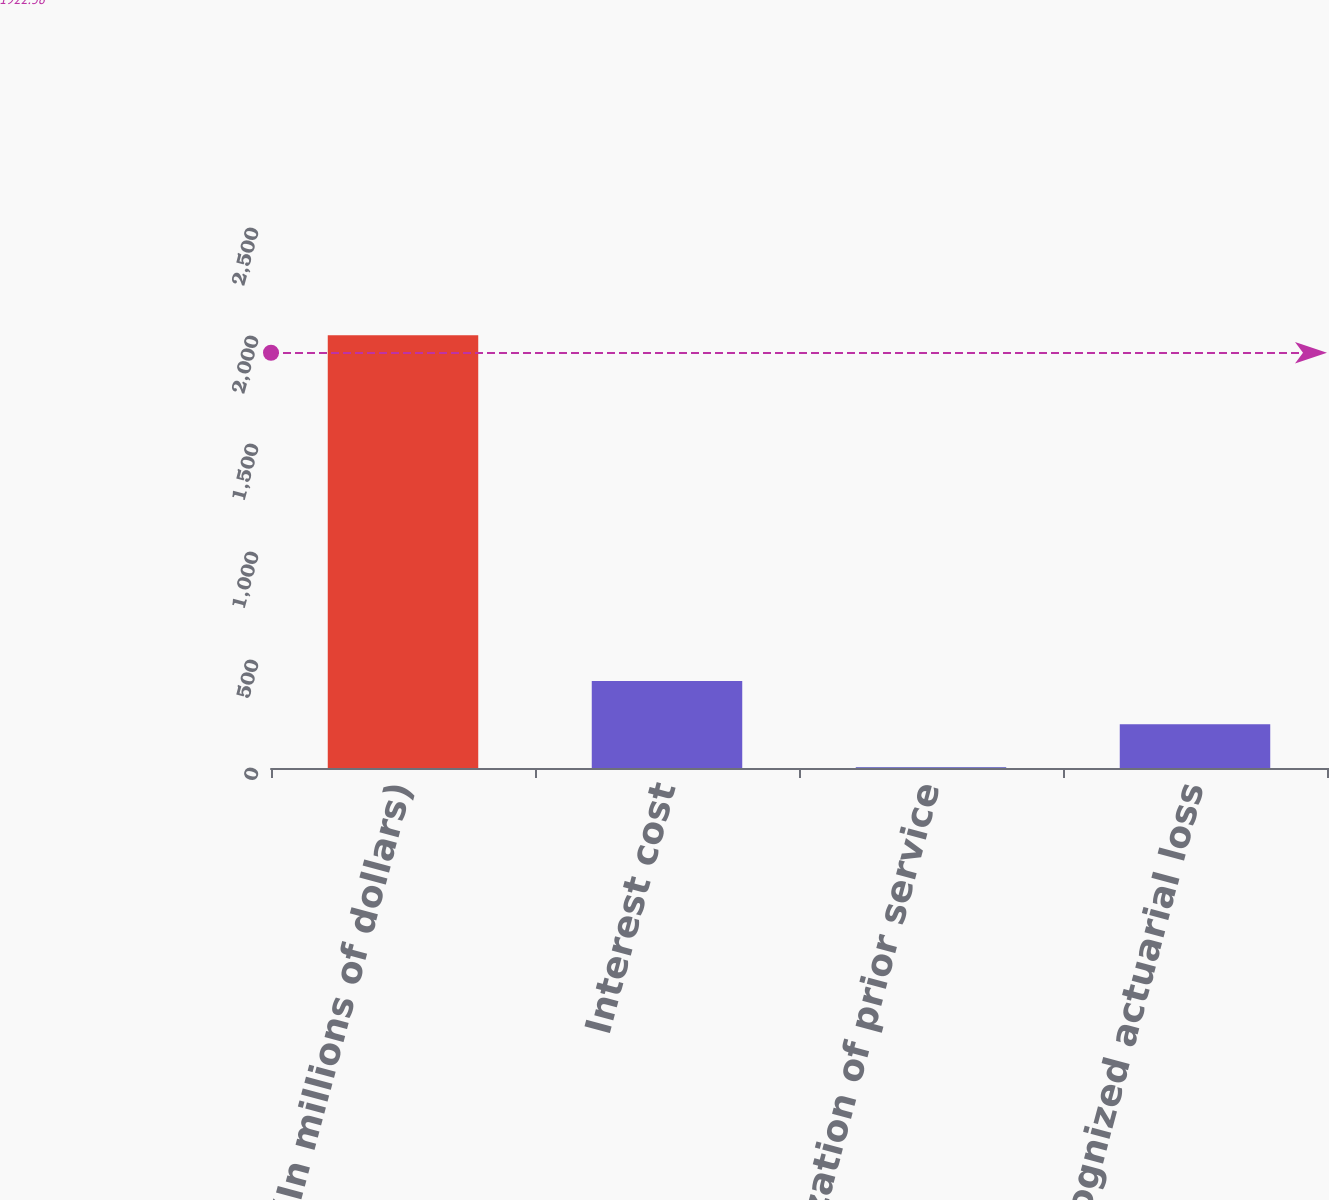<chart> <loc_0><loc_0><loc_500><loc_500><bar_chart><fcel>(In millions of dollars)<fcel>Interest cost<fcel>Amortization of prior service<fcel>Recognized actuarial loss<nl><fcel>2004<fcel>402.4<fcel>2<fcel>202.2<nl></chart> 